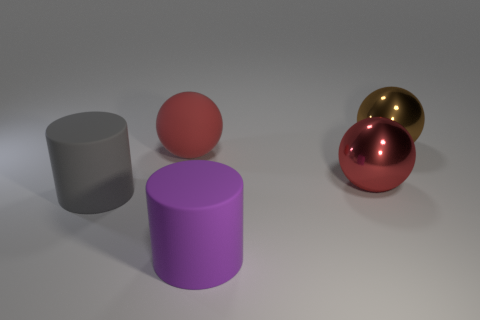How would you interpret the composition of these objects? The composition includes geometric shapes with a color palette that is both muted and vibrant. It suggests a study in contrasts—between the textures, as seen in the reflections on the spheres, and the shapes, featuring both cylinders and spheres. It could represent balance and diversity. Does the image convey any particular style or is it reminiscent of any artistic movements? The minimalist arrangement and focus on fundamental geometric forms are reminiscent of Constructivism or even certain aspects of Bauhaus, where the simplicity of form and function are celebrated. The clean lines and reflective surfaces also give it a modern, almost digital art aesthetic. 